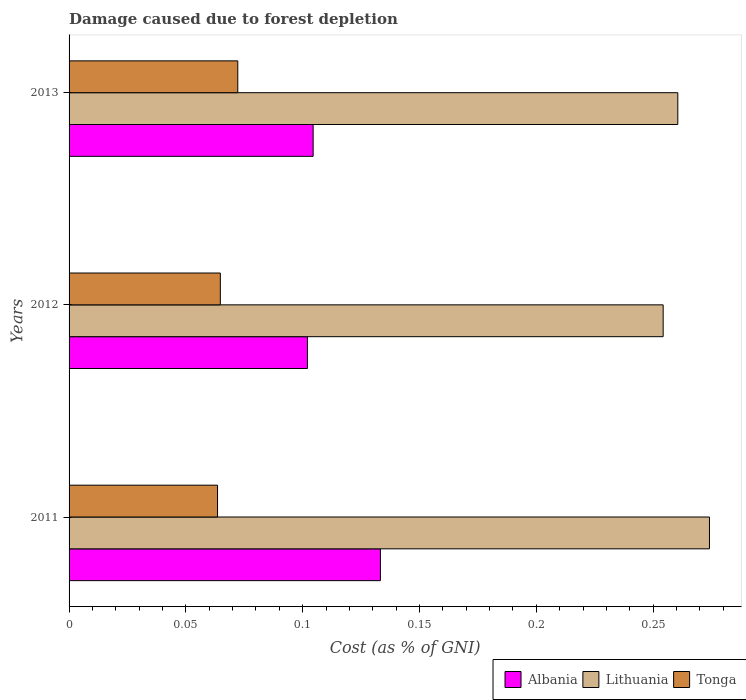Are the number of bars on each tick of the Y-axis equal?
Your answer should be very brief. Yes. How many bars are there on the 2nd tick from the bottom?
Offer a terse response. 3. What is the cost of damage caused due to forest depletion in Tonga in 2013?
Offer a terse response. 0.07. Across all years, what is the maximum cost of damage caused due to forest depletion in Lithuania?
Offer a terse response. 0.27. Across all years, what is the minimum cost of damage caused due to forest depletion in Tonga?
Offer a very short reply. 0.06. What is the total cost of damage caused due to forest depletion in Albania in the graph?
Offer a terse response. 0.34. What is the difference between the cost of damage caused due to forest depletion in Lithuania in 2011 and that in 2013?
Ensure brevity in your answer.  0.01. What is the difference between the cost of damage caused due to forest depletion in Albania in 2013 and the cost of damage caused due to forest depletion in Tonga in 2012?
Give a very brief answer. 0.04. What is the average cost of damage caused due to forest depletion in Lithuania per year?
Ensure brevity in your answer.  0.26. In the year 2012, what is the difference between the cost of damage caused due to forest depletion in Lithuania and cost of damage caused due to forest depletion in Albania?
Keep it short and to the point. 0.15. What is the ratio of the cost of damage caused due to forest depletion in Lithuania in 2012 to that in 2013?
Give a very brief answer. 0.98. Is the cost of damage caused due to forest depletion in Lithuania in 2011 less than that in 2013?
Provide a succinct answer. No. What is the difference between the highest and the second highest cost of damage caused due to forest depletion in Lithuania?
Ensure brevity in your answer.  0.01. What is the difference between the highest and the lowest cost of damage caused due to forest depletion in Albania?
Your answer should be very brief. 0.03. In how many years, is the cost of damage caused due to forest depletion in Lithuania greater than the average cost of damage caused due to forest depletion in Lithuania taken over all years?
Your answer should be very brief. 1. Is the sum of the cost of damage caused due to forest depletion in Tonga in 2011 and 2012 greater than the maximum cost of damage caused due to forest depletion in Lithuania across all years?
Keep it short and to the point. No. What does the 1st bar from the top in 2011 represents?
Keep it short and to the point. Tonga. What does the 1st bar from the bottom in 2013 represents?
Provide a short and direct response. Albania. How many years are there in the graph?
Your answer should be compact. 3. Are the values on the major ticks of X-axis written in scientific E-notation?
Provide a succinct answer. No. Does the graph contain any zero values?
Offer a terse response. No. Where does the legend appear in the graph?
Provide a succinct answer. Bottom right. What is the title of the graph?
Make the answer very short. Damage caused due to forest depletion. Does "Uzbekistan" appear as one of the legend labels in the graph?
Ensure brevity in your answer.  No. What is the label or title of the X-axis?
Offer a terse response. Cost (as % of GNI). What is the Cost (as % of GNI) of Albania in 2011?
Make the answer very short. 0.13. What is the Cost (as % of GNI) in Lithuania in 2011?
Your response must be concise. 0.27. What is the Cost (as % of GNI) of Tonga in 2011?
Give a very brief answer. 0.06. What is the Cost (as % of GNI) of Albania in 2012?
Ensure brevity in your answer.  0.1. What is the Cost (as % of GNI) of Lithuania in 2012?
Provide a succinct answer. 0.25. What is the Cost (as % of GNI) in Tonga in 2012?
Make the answer very short. 0.06. What is the Cost (as % of GNI) of Albania in 2013?
Offer a terse response. 0.1. What is the Cost (as % of GNI) of Lithuania in 2013?
Ensure brevity in your answer.  0.26. What is the Cost (as % of GNI) of Tonga in 2013?
Provide a short and direct response. 0.07. Across all years, what is the maximum Cost (as % of GNI) in Albania?
Your response must be concise. 0.13. Across all years, what is the maximum Cost (as % of GNI) in Lithuania?
Keep it short and to the point. 0.27. Across all years, what is the maximum Cost (as % of GNI) of Tonga?
Your answer should be compact. 0.07. Across all years, what is the minimum Cost (as % of GNI) in Albania?
Provide a succinct answer. 0.1. Across all years, what is the minimum Cost (as % of GNI) in Lithuania?
Your answer should be compact. 0.25. Across all years, what is the minimum Cost (as % of GNI) of Tonga?
Offer a very short reply. 0.06. What is the total Cost (as % of GNI) in Albania in the graph?
Make the answer very short. 0.34. What is the total Cost (as % of GNI) of Lithuania in the graph?
Give a very brief answer. 0.79. What is the total Cost (as % of GNI) of Tonga in the graph?
Make the answer very short. 0.2. What is the difference between the Cost (as % of GNI) in Albania in 2011 and that in 2012?
Make the answer very short. 0.03. What is the difference between the Cost (as % of GNI) of Lithuania in 2011 and that in 2012?
Your answer should be compact. 0.02. What is the difference between the Cost (as % of GNI) in Tonga in 2011 and that in 2012?
Provide a short and direct response. -0. What is the difference between the Cost (as % of GNI) of Albania in 2011 and that in 2013?
Ensure brevity in your answer.  0.03. What is the difference between the Cost (as % of GNI) of Lithuania in 2011 and that in 2013?
Give a very brief answer. 0.01. What is the difference between the Cost (as % of GNI) in Tonga in 2011 and that in 2013?
Provide a short and direct response. -0.01. What is the difference between the Cost (as % of GNI) in Albania in 2012 and that in 2013?
Keep it short and to the point. -0. What is the difference between the Cost (as % of GNI) in Lithuania in 2012 and that in 2013?
Your answer should be very brief. -0.01. What is the difference between the Cost (as % of GNI) in Tonga in 2012 and that in 2013?
Offer a terse response. -0.01. What is the difference between the Cost (as % of GNI) of Albania in 2011 and the Cost (as % of GNI) of Lithuania in 2012?
Make the answer very short. -0.12. What is the difference between the Cost (as % of GNI) in Albania in 2011 and the Cost (as % of GNI) in Tonga in 2012?
Ensure brevity in your answer.  0.07. What is the difference between the Cost (as % of GNI) in Lithuania in 2011 and the Cost (as % of GNI) in Tonga in 2012?
Keep it short and to the point. 0.21. What is the difference between the Cost (as % of GNI) of Albania in 2011 and the Cost (as % of GNI) of Lithuania in 2013?
Keep it short and to the point. -0.13. What is the difference between the Cost (as % of GNI) of Albania in 2011 and the Cost (as % of GNI) of Tonga in 2013?
Make the answer very short. 0.06. What is the difference between the Cost (as % of GNI) of Lithuania in 2011 and the Cost (as % of GNI) of Tonga in 2013?
Give a very brief answer. 0.2. What is the difference between the Cost (as % of GNI) of Albania in 2012 and the Cost (as % of GNI) of Lithuania in 2013?
Ensure brevity in your answer.  -0.16. What is the difference between the Cost (as % of GNI) in Albania in 2012 and the Cost (as % of GNI) in Tonga in 2013?
Your response must be concise. 0.03. What is the difference between the Cost (as % of GNI) of Lithuania in 2012 and the Cost (as % of GNI) of Tonga in 2013?
Provide a short and direct response. 0.18. What is the average Cost (as % of GNI) of Albania per year?
Give a very brief answer. 0.11. What is the average Cost (as % of GNI) of Lithuania per year?
Keep it short and to the point. 0.26. What is the average Cost (as % of GNI) of Tonga per year?
Your answer should be very brief. 0.07. In the year 2011, what is the difference between the Cost (as % of GNI) in Albania and Cost (as % of GNI) in Lithuania?
Provide a short and direct response. -0.14. In the year 2011, what is the difference between the Cost (as % of GNI) of Albania and Cost (as % of GNI) of Tonga?
Provide a succinct answer. 0.07. In the year 2011, what is the difference between the Cost (as % of GNI) in Lithuania and Cost (as % of GNI) in Tonga?
Ensure brevity in your answer.  0.21. In the year 2012, what is the difference between the Cost (as % of GNI) in Albania and Cost (as % of GNI) in Lithuania?
Offer a terse response. -0.15. In the year 2012, what is the difference between the Cost (as % of GNI) of Albania and Cost (as % of GNI) of Tonga?
Ensure brevity in your answer.  0.04. In the year 2012, what is the difference between the Cost (as % of GNI) in Lithuania and Cost (as % of GNI) in Tonga?
Make the answer very short. 0.19. In the year 2013, what is the difference between the Cost (as % of GNI) of Albania and Cost (as % of GNI) of Lithuania?
Make the answer very short. -0.16. In the year 2013, what is the difference between the Cost (as % of GNI) of Albania and Cost (as % of GNI) of Tonga?
Your response must be concise. 0.03. In the year 2013, what is the difference between the Cost (as % of GNI) in Lithuania and Cost (as % of GNI) in Tonga?
Offer a terse response. 0.19. What is the ratio of the Cost (as % of GNI) in Albania in 2011 to that in 2012?
Offer a terse response. 1.31. What is the ratio of the Cost (as % of GNI) in Lithuania in 2011 to that in 2012?
Provide a succinct answer. 1.08. What is the ratio of the Cost (as % of GNI) of Tonga in 2011 to that in 2012?
Offer a very short reply. 0.98. What is the ratio of the Cost (as % of GNI) in Albania in 2011 to that in 2013?
Make the answer very short. 1.28. What is the ratio of the Cost (as % of GNI) of Lithuania in 2011 to that in 2013?
Provide a short and direct response. 1.05. What is the ratio of the Cost (as % of GNI) in Tonga in 2011 to that in 2013?
Offer a terse response. 0.88. What is the ratio of the Cost (as % of GNI) in Albania in 2012 to that in 2013?
Give a very brief answer. 0.98. What is the ratio of the Cost (as % of GNI) in Lithuania in 2012 to that in 2013?
Provide a succinct answer. 0.98. What is the ratio of the Cost (as % of GNI) in Tonga in 2012 to that in 2013?
Make the answer very short. 0.9. What is the difference between the highest and the second highest Cost (as % of GNI) in Albania?
Your answer should be very brief. 0.03. What is the difference between the highest and the second highest Cost (as % of GNI) in Lithuania?
Your response must be concise. 0.01. What is the difference between the highest and the second highest Cost (as % of GNI) in Tonga?
Keep it short and to the point. 0.01. What is the difference between the highest and the lowest Cost (as % of GNI) of Albania?
Ensure brevity in your answer.  0.03. What is the difference between the highest and the lowest Cost (as % of GNI) in Lithuania?
Ensure brevity in your answer.  0.02. What is the difference between the highest and the lowest Cost (as % of GNI) of Tonga?
Your answer should be very brief. 0.01. 